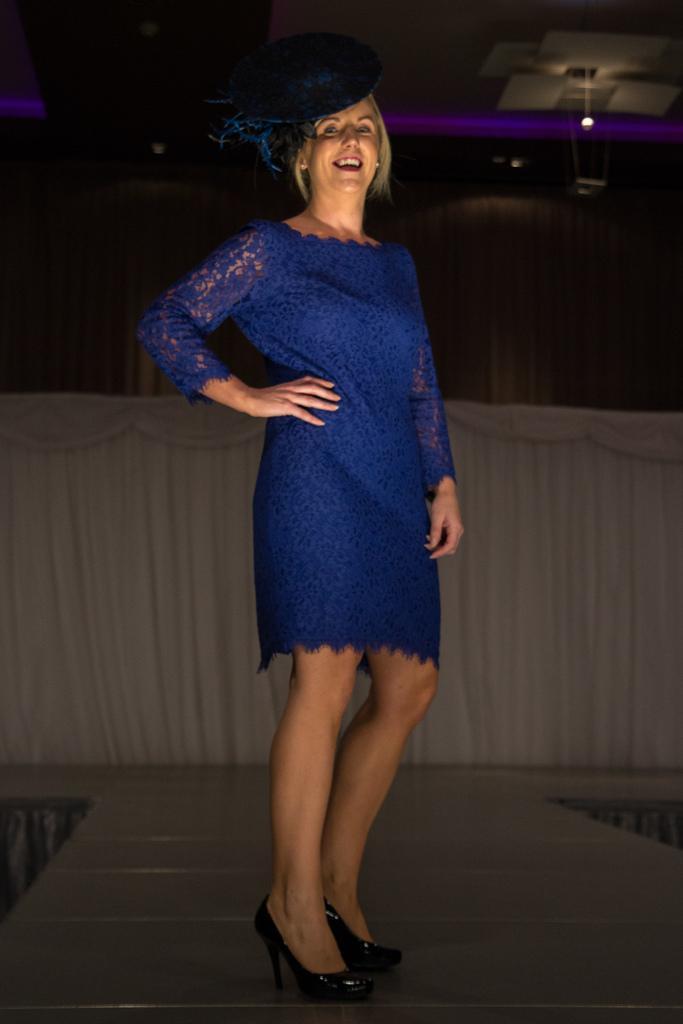Describe this image in one or two sentences. In this image we can see a woman standing and smiling, behind her we can see a curtain and the background is dark. 